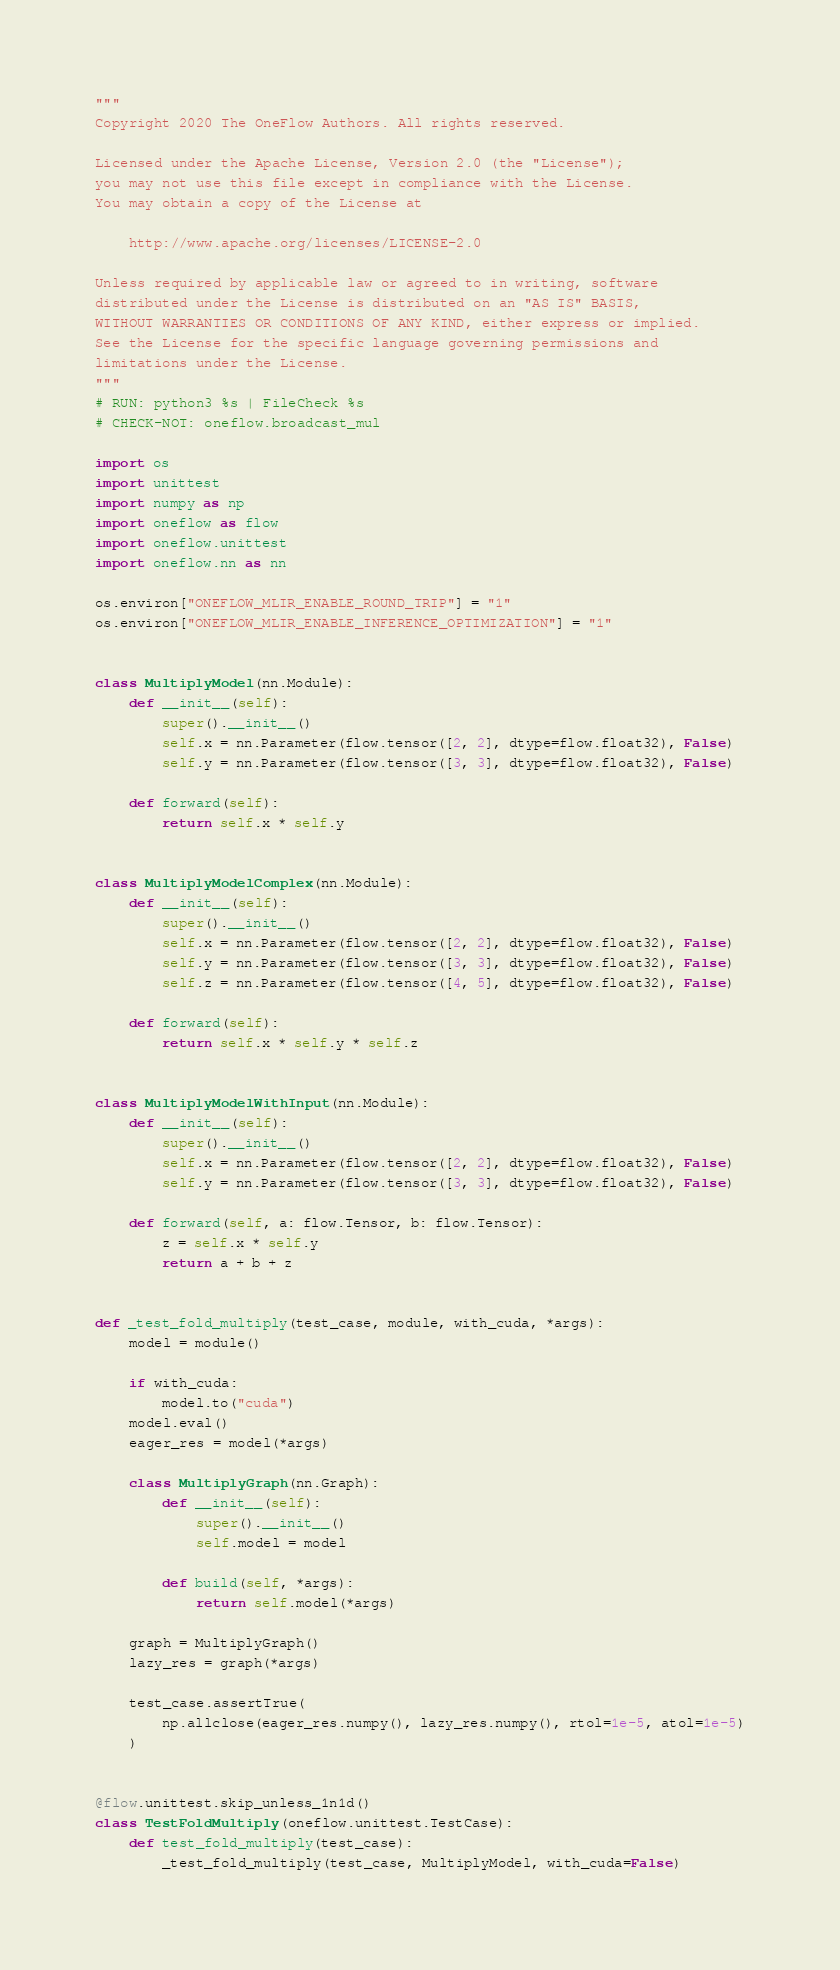<code> <loc_0><loc_0><loc_500><loc_500><_Python_>"""
Copyright 2020 The OneFlow Authors. All rights reserved.

Licensed under the Apache License, Version 2.0 (the "License");
you may not use this file except in compliance with the License.
You may obtain a copy of the License at

    http://www.apache.org/licenses/LICENSE-2.0

Unless required by applicable law or agreed to in writing, software
distributed under the License is distributed on an "AS IS" BASIS,
WITHOUT WARRANTIES OR CONDITIONS OF ANY KIND, either express or implied.
See the License for the specific language governing permissions and
limitations under the License.
"""
# RUN: python3 %s | FileCheck %s
# CHECK-NOT: oneflow.broadcast_mul

import os
import unittest
import numpy as np
import oneflow as flow
import oneflow.unittest
import oneflow.nn as nn

os.environ["ONEFLOW_MLIR_ENABLE_ROUND_TRIP"] = "1"
os.environ["ONEFLOW_MLIR_ENABLE_INFERENCE_OPTIMIZATION"] = "1"


class MultiplyModel(nn.Module):
    def __init__(self):
        super().__init__()
        self.x = nn.Parameter(flow.tensor([2, 2], dtype=flow.float32), False)
        self.y = nn.Parameter(flow.tensor([3, 3], dtype=flow.float32), False)

    def forward(self):
        return self.x * self.y


class MultiplyModelComplex(nn.Module):
    def __init__(self):
        super().__init__()
        self.x = nn.Parameter(flow.tensor([2, 2], dtype=flow.float32), False)
        self.y = nn.Parameter(flow.tensor([3, 3], dtype=flow.float32), False)
        self.z = nn.Parameter(flow.tensor([4, 5], dtype=flow.float32), False)

    def forward(self):
        return self.x * self.y * self.z


class MultiplyModelWithInput(nn.Module):
    def __init__(self):
        super().__init__()
        self.x = nn.Parameter(flow.tensor([2, 2], dtype=flow.float32), False)
        self.y = nn.Parameter(flow.tensor([3, 3], dtype=flow.float32), False)

    def forward(self, a: flow.Tensor, b: flow.Tensor):
        z = self.x * self.y
        return a + b + z


def _test_fold_multiply(test_case, module, with_cuda, *args):
    model = module()

    if with_cuda:
        model.to("cuda")
    model.eval()
    eager_res = model(*args)

    class MultiplyGraph(nn.Graph):
        def __init__(self):
            super().__init__()
            self.model = model

        def build(self, *args):
            return self.model(*args)

    graph = MultiplyGraph()
    lazy_res = graph(*args)

    test_case.assertTrue(
        np.allclose(eager_res.numpy(), lazy_res.numpy(), rtol=1e-5, atol=1e-5)
    )


@flow.unittest.skip_unless_1n1d()
class TestFoldMultiply(oneflow.unittest.TestCase):
    def test_fold_multiply(test_case):
        _test_fold_multiply(test_case, MultiplyModel, with_cuda=False)</code> 